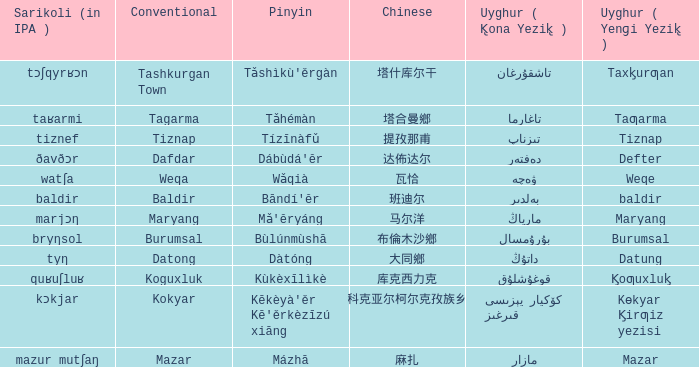Determine the pinyin for kɵkyar k̡irƣiz yezisi. Kēkèyà'ěr Kē'ěrkèzīzú xiāng. 